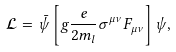Convert formula to latex. <formula><loc_0><loc_0><loc_500><loc_500>\mathcal { L } = \bar { \psi } \left [ g \frac { e } { 2 m _ { l } } \sigma ^ { \mu \nu } F _ { \mu \nu } \right ] \psi ,</formula> 